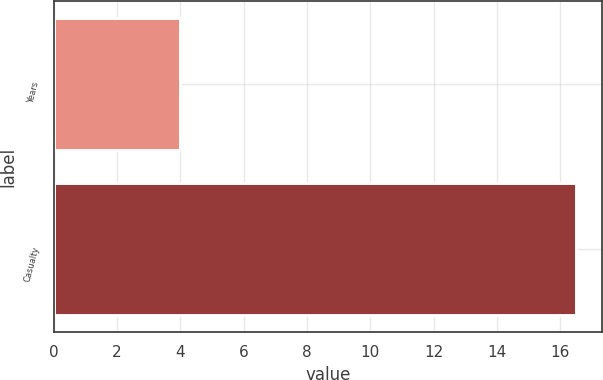Convert chart. <chart><loc_0><loc_0><loc_500><loc_500><bar_chart><fcel>Years<fcel>Casualty<nl><fcel>4<fcel>16.5<nl></chart> 